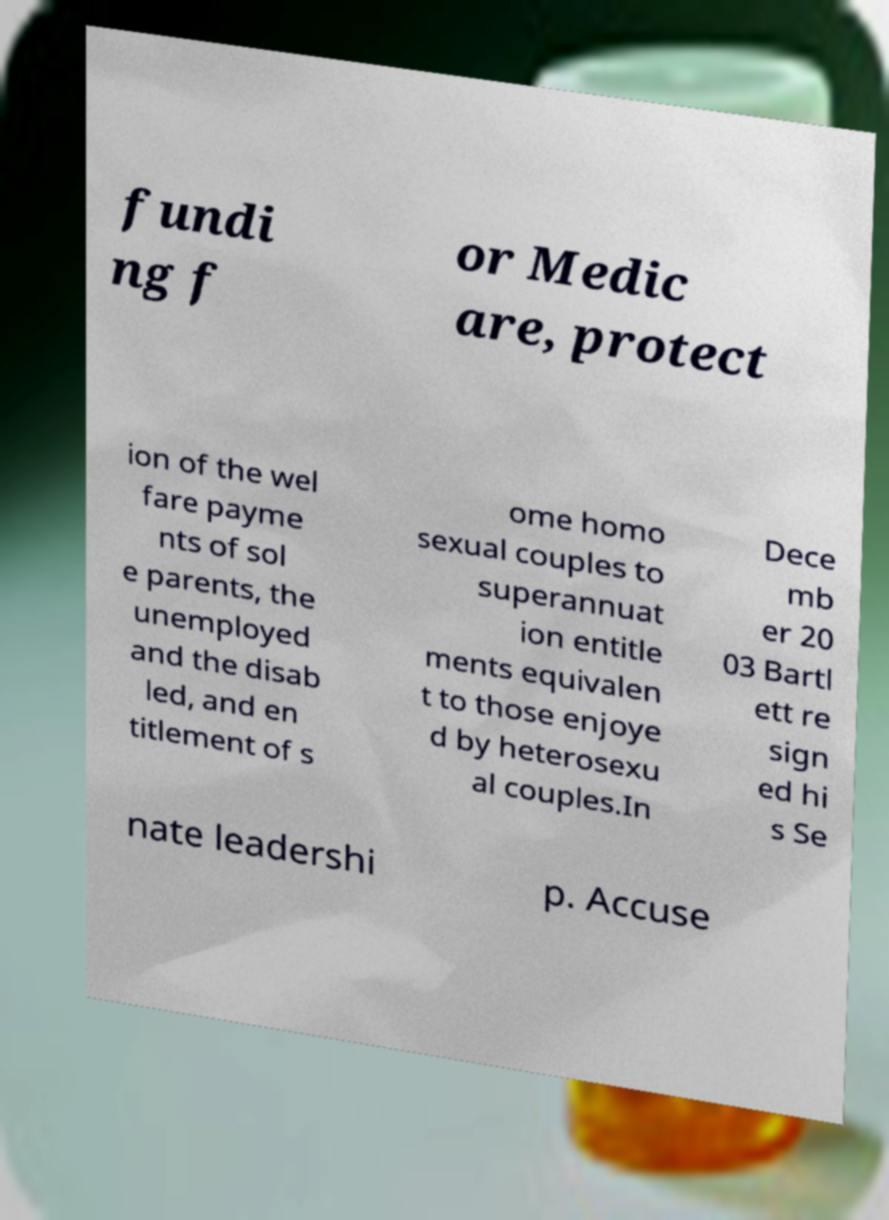Please read and relay the text visible in this image. What does it say? fundi ng f or Medic are, protect ion of the wel fare payme nts of sol e parents, the unemployed and the disab led, and en titlement of s ome homo sexual couples to superannuat ion entitle ments equivalen t to those enjoye d by heterosexu al couples.In Dece mb er 20 03 Bartl ett re sign ed hi s Se nate leadershi p. Accuse 